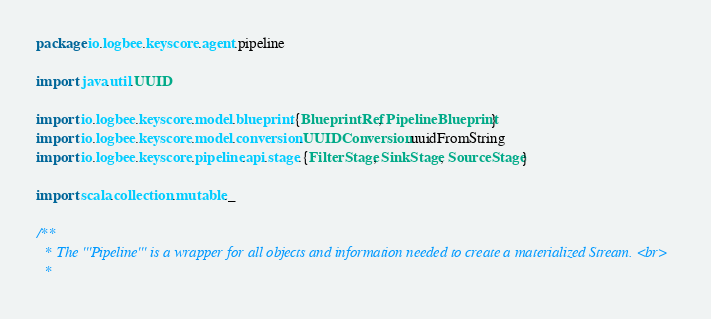Convert code to text. <code><loc_0><loc_0><loc_500><loc_500><_Scala_>package io.logbee.keyscore.agent.pipeline

import java.util.UUID

import io.logbee.keyscore.model.blueprint.{BlueprintRef, PipelineBlueprint}
import io.logbee.keyscore.model.conversion.UUIDConversion.uuidFromString
import io.logbee.keyscore.pipeline.api.stage.{FilterStage, SinkStage, SourceStage}

import scala.collection.mutable._

/**
  * The '''Pipeline''' is a wrapper for all objects and information needed to create a materialized Stream. <br>
  *</code> 